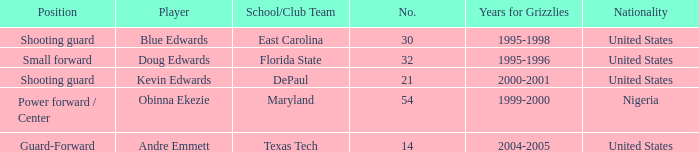Which position did kevin edwards play for Shooting guard. 